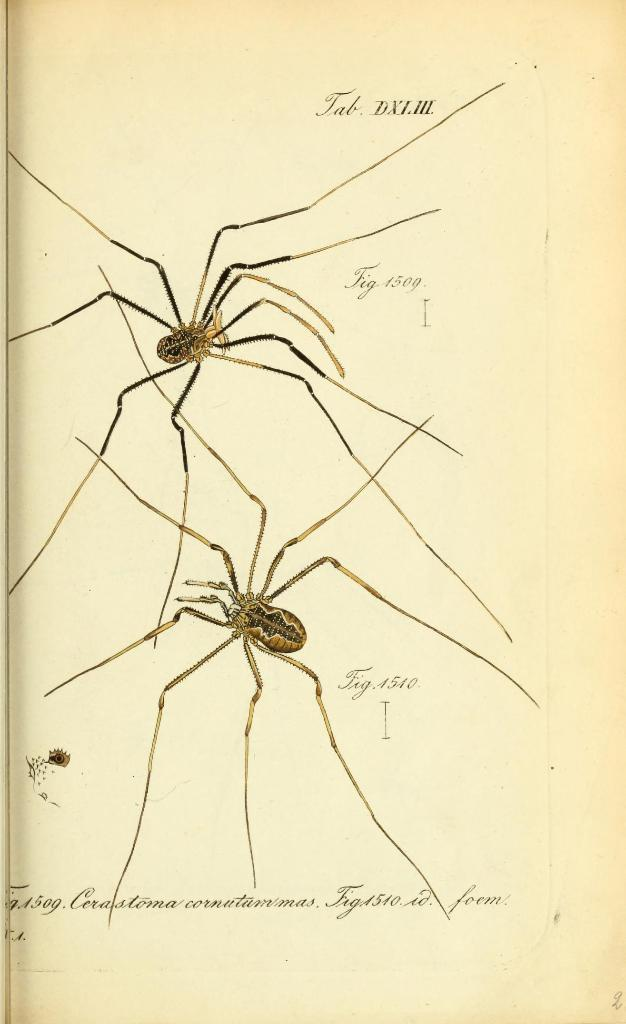What is present on the paper in the image? There are 2 spiders on the paper. Can you describe the appearance of the spiders? One spider is brown in color, and the other spider is black in color. What else can be seen on the paper besides the spiders? There are words and numbers written on the paper. How many rabbits can be seen climbing the mountain in the image? There are no rabbits or mountains present in the image. What type of cover is used to protect the spiders from the elements in the image? There is no cover present in the image; the spiders are on a paper without any additional protection. 